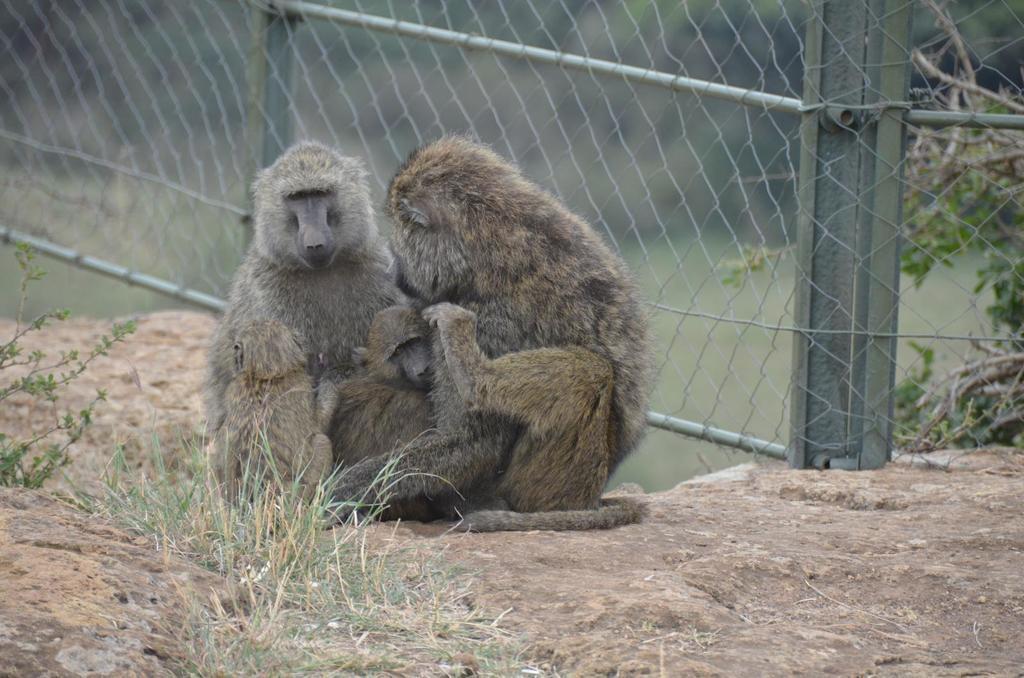How would you summarize this image in a sentence or two? In this picture, we can see three monkeys on the ground, and we can see some grass, plants, fencing and the background is blurred. 